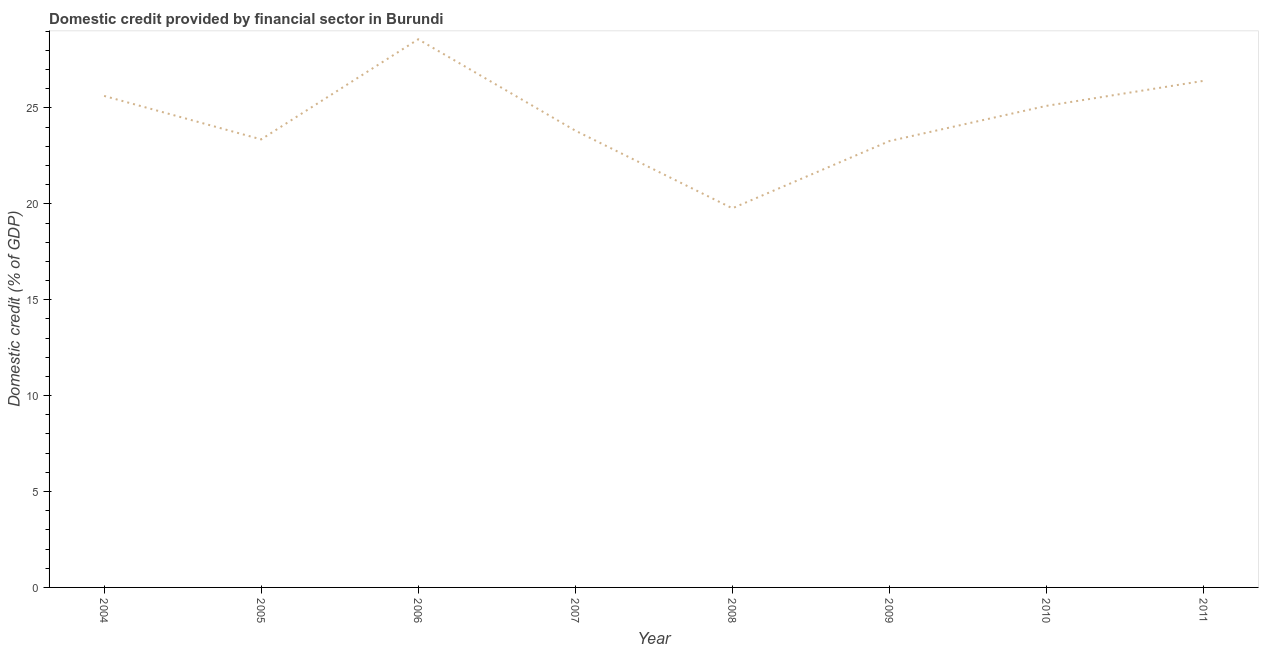What is the domestic credit provided by financial sector in 2009?
Offer a terse response. 23.27. Across all years, what is the maximum domestic credit provided by financial sector?
Make the answer very short. 28.58. Across all years, what is the minimum domestic credit provided by financial sector?
Give a very brief answer. 19.77. In which year was the domestic credit provided by financial sector maximum?
Ensure brevity in your answer.  2006. In which year was the domestic credit provided by financial sector minimum?
Give a very brief answer. 2008. What is the sum of the domestic credit provided by financial sector?
Provide a succinct answer. 195.95. What is the difference between the domestic credit provided by financial sector in 2004 and 2007?
Offer a terse response. 1.81. What is the average domestic credit provided by financial sector per year?
Provide a short and direct response. 24.49. What is the median domestic credit provided by financial sector?
Your answer should be compact. 24.46. In how many years, is the domestic credit provided by financial sector greater than 4 %?
Ensure brevity in your answer.  8. Do a majority of the years between 2004 and 2005 (inclusive) have domestic credit provided by financial sector greater than 24 %?
Provide a succinct answer. No. What is the ratio of the domestic credit provided by financial sector in 2004 to that in 2005?
Ensure brevity in your answer.  1.1. Is the difference between the domestic credit provided by financial sector in 2005 and 2010 greater than the difference between any two years?
Your response must be concise. No. What is the difference between the highest and the second highest domestic credit provided by financial sector?
Offer a very short reply. 2.17. What is the difference between the highest and the lowest domestic credit provided by financial sector?
Your response must be concise. 8.81. In how many years, is the domestic credit provided by financial sector greater than the average domestic credit provided by financial sector taken over all years?
Your answer should be compact. 4. How many years are there in the graph?
Offer a terse response. 8. What is the difference between two consecutive major ticks on the Y-axis?
Offer a very short reply. 5. Does the graph contain any zero values?
Offer a very short reply. No. Does the graph contain grids?
Offer a terse response. No. What is the title of the graph?
Your answer should be compact. Domestic credit provided by financial sector in Burundi. What is the label or title of the Y-axis?
Keep it short and to the point. Domestic credit (% of GDP). What is the Domestic credit (% of GDP) of 2004?
Give a very brief answer. 25.63. What is the Domestic credit (% of GDP) in 2005?
Your response must be concise. 23.36. What is the Domestic credit (% of GDP) of 2006?
Your response must be concise. 28.58. What is the Domestic credit (% of GDP) in 2007?
Offer a terse response. 23.82. What is the Domestic credit (% of GDP) in 2008?
Keep it short and to the point. 19.77. What is the Domestic credit (% of GDP) of 2009?
Your answer should be compact. 23.27. What is the Domestic credit (% of GDP) in 2010?
Offer a terse response. 25.11. What is the Domestic credit (% of GDP) in 2011?
Make the answer very short. 26.41. What is the difference between the Domestic credit (% of GDP) in 2004 and 2005?
Make the answer very short. 2.27. What is the difference between the Domestic credit (% of GDP) in 2004 and 2006?
Give a very brief answer. -2.95. What is the difference between the Domestic credit (% of GDP) in 2004 and 2007?
Provide a succinct answer. 1.81. What is the difference between the Domestic credit (% of GDP) in 2004 and 2008?
Your response must be concise. 5.86. What is the difference between the Domestic credit (% of GDP) in 2004 and 2009?
Make the answer very short. 2.35. What is the difference between the Domestic credit (% of GDP) in 2004 and 2010?
Your answer should be compact. 0.52. What is the difference between the Domestic credit (% of GDP) in 2004 and 2011?
Keep it short and to the point. -0.79. What is the difference between the Domestic credit (% of GDP) in 2005 and 2006?
Your answer should be compact. -5.22. What is the difference between the Domestic credit (% of GDP) in 2005 and 2007?
Offer a terse response. -0.46. What is the difference between the Domestic credit (% of GDP) in 2005 and 2008?
Your answer should be compact. 3.59. What is the difference between the Domestic credit (% of GDP) in 2005 and 2009?
Offer a terse response. 0.09. What is the difference between the Domestic credit (% of GDP) in 2005 and 2010?
Provide a short and direct response. -1.75. What is the difference between the Domestic credit (% of GDP) in 2005 and 2011?
Your answer should be very brief. -3.05. What is the difference between the Domestic credit (% of GDP) in 2006 and 2007?
Your response must be concise. 4.76. What is the difference between the Domestic credit (% of GDP) in 2006 and 2008?
Your answer should be very brief. 8.81. What is the difference between the Domestic credit (% of GDP) in 2006 and 2009?
Offer a very short reply. 5.31. What is the difference between the Domestic credit (% of GDP) in 2006 and 2010?
Make the answer very short. 3.47. What is the difference between the Domestic credit (% of GDP) in 2006 and 2011?
Give a very brief answer. 2.17. What is the difference between the Domestic credit (% of GDP) in 2007 and 2008?
Keep it short and to the point. 4.05. What is the difference between the Domestic credit (% of GDP) in 2007 and 2009?
Your answer should be compact. 0.54. What is the difference between the Domestic credit (% of GDP) in 2007 and 2010?
Provide a short and direct response. -1.29. What is the difference between the Domestic credit (% of GDP) in 2007 and 2011?
Provide a short and direct response. -2.59. What is the difference between the Domestic credit (% of GDP) in 2008 and 2009?
Keep it short and to the point. -3.51. What is the difference between the Domestic credit (% of GDP) in 2008 and 2010?
Your answer should be very brief. -5.34. What is the difference between the Domestic credit (% of GDP) in 2008 and 2011?
Keep it short and to the point. -6.64. What is the difference between the Domestic credit (% of GDP) in 2009 and 2010?
Your answer should be compact. -1.84. What is the difference between the Domestic credit (% of GDP) in 2009 and 2011?
Offer a terse response. -3.14. What is the difference between the Domestic credit (% of GDP) in 2010 and 2011?
Make the answer very short. -1.3. What is the ratio of the Domestic credit (% of GDP) in 2004 to that in 2005?
Keep it short and to the point. 1.1. What is the ratio of the Domestic credit (% of GDP) in 2004 to that in 2006?
Offer a terse response. 0.9. What is the ratio of the Domestic credit (% of GDP) in 2004 to that in 2007?
Offer a very short reply. 1.08. What is the ratio of the Domestic credit (% of GDP) in 2004 to that in 2008?
Make the answer very short. 1.3. What is the ratio of the Domestic credit (% of GDP) in 2004 to that in 2009?
Offer a very short reply. 1.1. What is the ratio of the Domestic credit (% of GDP) in 2005 to that in 2006?
Your answer should be compact. 0.82. What is the ratio of the Domestic credit (% of GDP) in 2005 to that in 2007?
Offer a terse response. 0.98. What is the ratio of the Domestic credit (% of GDP) in 2005 to that in 2008?
Provide a succinct answer. 1.18. What is the ratio of the Domestic credit (% of GDP) in 2005 to that in 2010?
Give a very brief answer. 0.93. What is the ratio of the Domestic credit (% of GDP) in 2005 to that in 2011?
Offer a terse response. 0.88. What is the ratio of the Domestic credit (% of GDP) in 2006 to that in 2007?
Your answer should be very brief. 1.2. What is the ratio of the Domestic credit (% of GDP) in 2006 to that in 2008?
Your answer should be compact. 1.45. What is the ratio of the Domestic credit (% of GDP) in 2006 to that in 2009?
Make the answer very short. 1.23. What is the ratio of the Domestic credit (% of GDP) in 2006 to that in 2010?
Your answer should be very brief. 1.14. What is the ratio of the Domestic credit (% of GDP) in 2006 to that in 2011?
Provide a short and direct response. 1.08. What is the ratio of the Domestic credit (% of GDP) in 2007 to that in 2008?
Offer a terse response. 1.21. What is the ratio of the Domestic credit (% of GDP) in 2007 to that in 2010?
Your response must be concise. 0.95. What is the ratio of the Domestic credit (% of GDP) in 2007 to that in 2011?
Keep it short and to the point. 0.9. What is the ratio of the Domestic credit (% of GDP) in 2008 to that in 2009?
Your answer should be compact. 0.85. What is the ratio of the Domestic credit (% of GDP) in 2008 to that in 2010?
Keep it short and to the point. 0.79. What is the ratio of the Domestic credit (% of GDP) in 2008 to that in 2011?
Give a very brief answer. 0.75. What is the ratio of the Domestic credit (% of GDP) in 2009 to that in 2010?
Keep it short and to the point. 0.93. What is the ratio of the Domestic credit (% of GDP) in 2009 to that in 2011?
Your answer should be compact. 0.88. What is the ratio of the Domestic credit (% of GDP) in 2010 to that in 2011?
Keep it short and to the point. 0.95. 